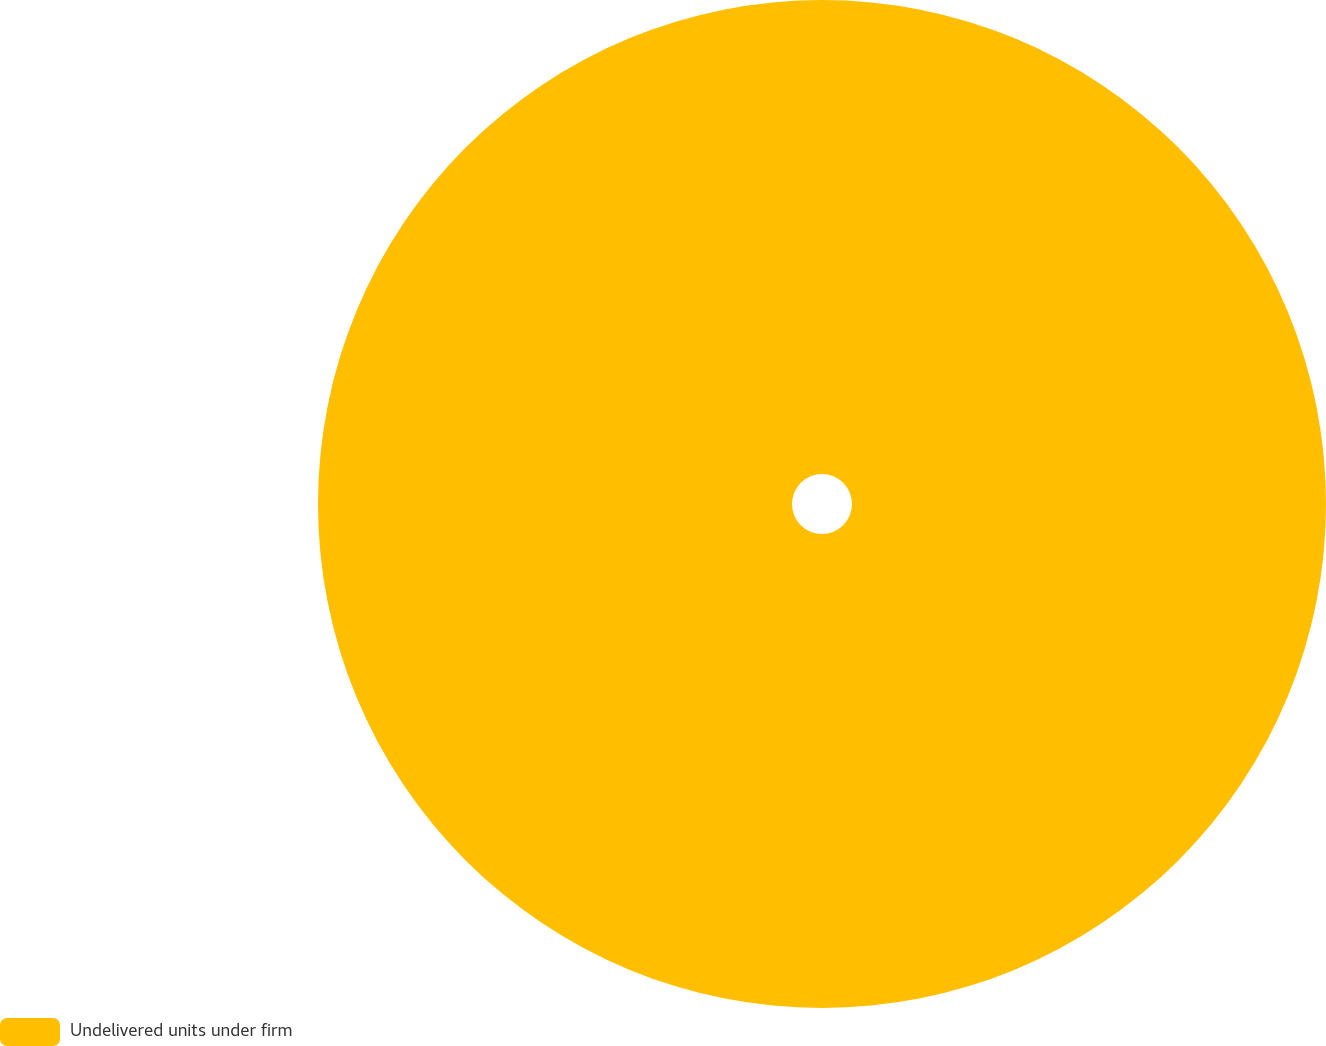Convert chart. <chart><loc_0><loc_0><loc_500><loc_500><pie_chart><fcel>Undelivered units under firm<nl><fcel>100.0%<nl></chart> 